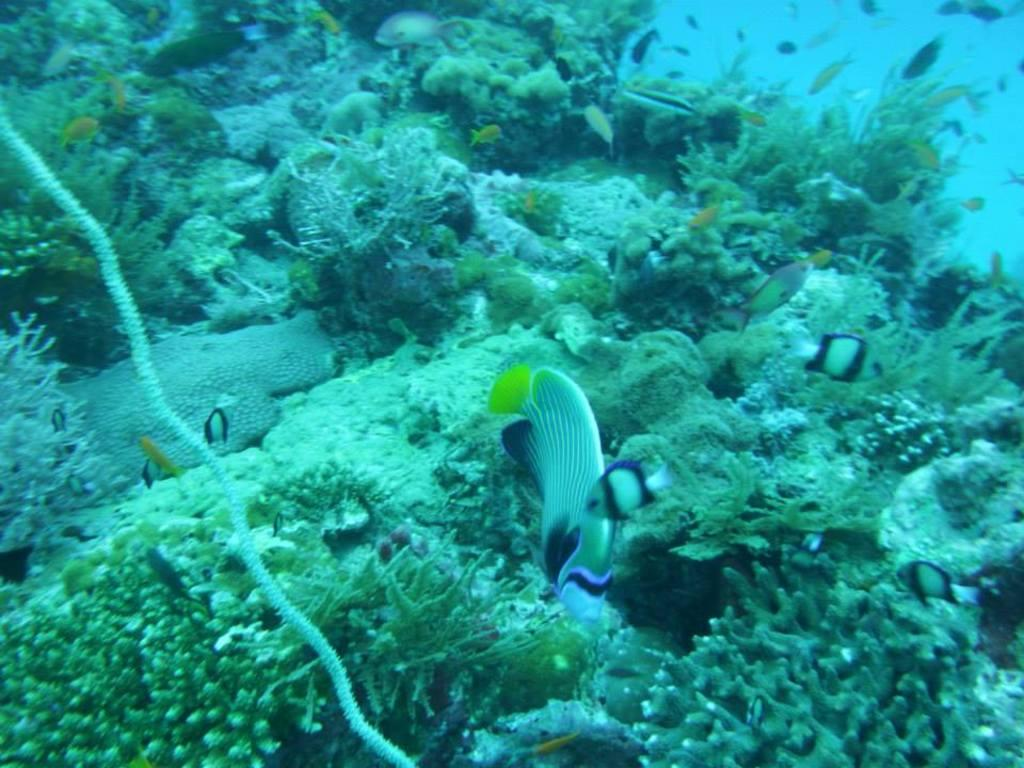What type of animals can be seen in the water in the image? There are small fishes in the water. What else can be found in the water besides the fishes? There are small plants in the water. How many pies are floating in the water in the image? There are no pies present in the image; it features small fishes and plants in the water. Can you see any signs of destruction in the image? The image does not show any signs of destruction; it features small fishes and plants in the water. 